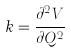<formula> <loc_0><loc_0><loc_500><loc_500>k = \frac { \partial ^ { 2 } V } { \partial Q ^ { 2 } }</formula> 